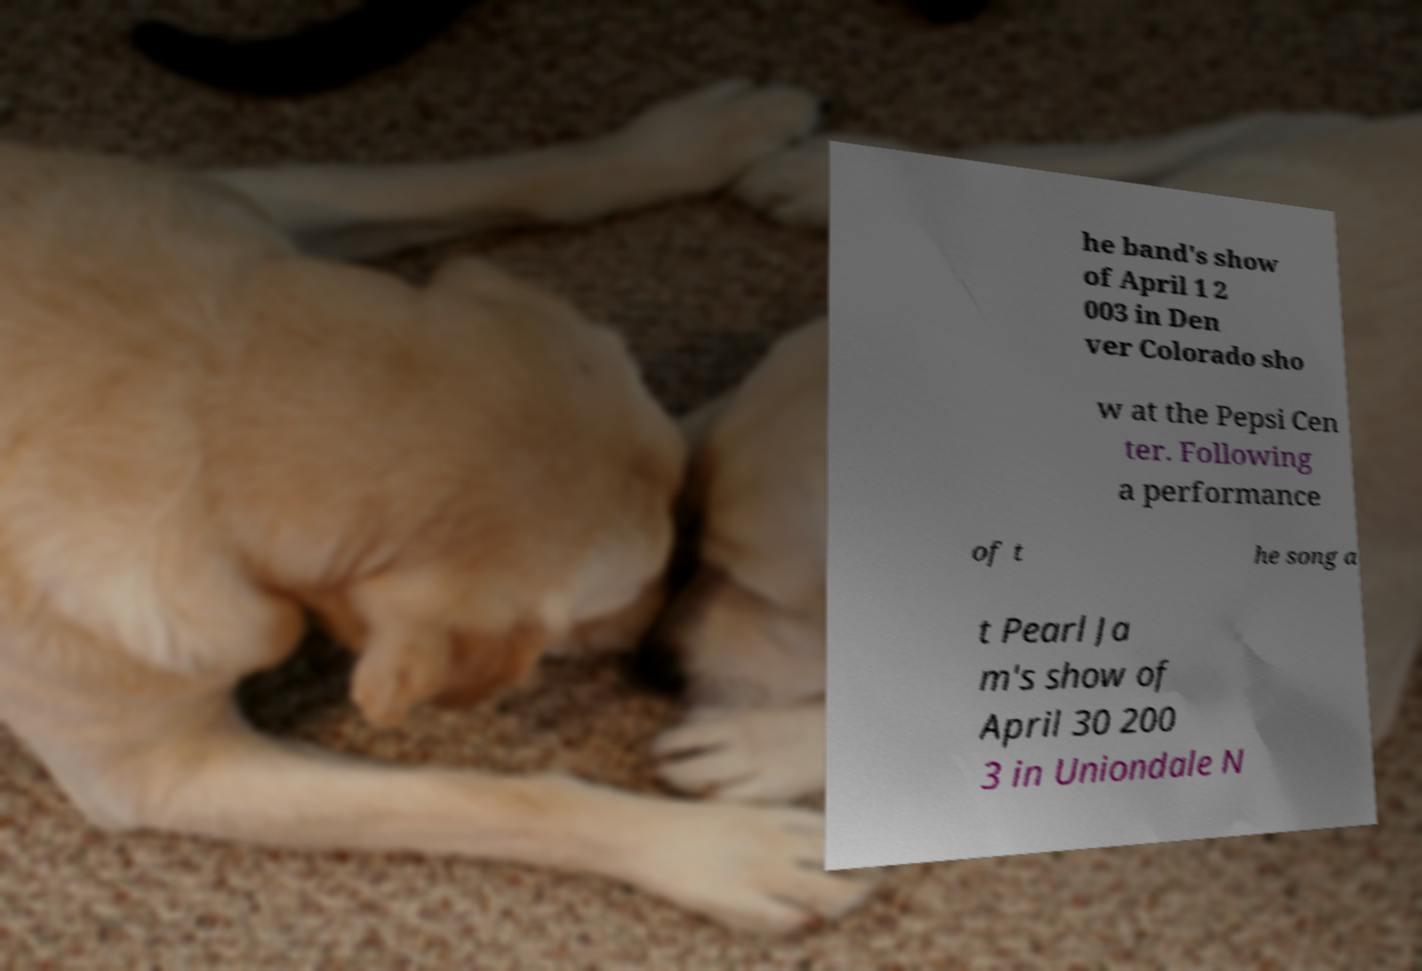For documentation purposes, I need the text within this image transcribed. Could you provide that? he band's show of April 1 2 003 in Den ver Colorado sho w at the Pepsi Cen ter. Following a performance of t he song a t Pearl Ja m's show of April 30 200 3 in Uniondale N 